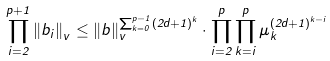Convert formula to latex. <formula><loc_0><loc_0><loc_500><loc_500>\prod _ { i = 2 } ^ { p + 1 } \left \| b _ { i } \right \| _ { v } \leq \left \| b \right \| _ { v } ^ { \sum _ { k = 0 } ^ { p - 1 } ( 2 d + 1 ) ^ { k } } \cdot \prod _ { i = 2 } ^ { p } \prod _ { k = i } ^ { p } \mu _ { k } ^ { ( 2 d + 1 ) ^ { k - i } }</formula> 